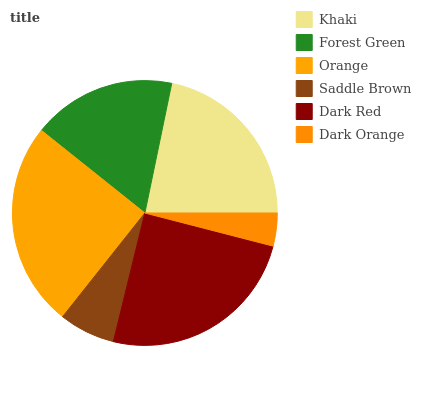Is Dark Orange the minimum?
Answer yes or no. Yes. Is Orange the maximum?
Answer yes or no. Yes. Is Forest Green the minimum?
Answer yes or no. No. Is Forest Green the maximum?
Answer yes or no. No. Is Khaki greater than Forest Green?
Answer yes or no. Yes. Is Forest Green less than Khaki?
Answer yes or no. Yes. Is Forest Green greater than Khaki?
Answer yes or no. No. Is Khaki less than Forest Green?
Answer yes or no. No. Is Khaki the high median?
Answer yes or no. Yes. Is Forest Green the low median?
Answer yes or no. Yes. Is Dark Orange the high median?
Answer yes or no. No. Is Khaki the low median?
Answer yes or no. No. 